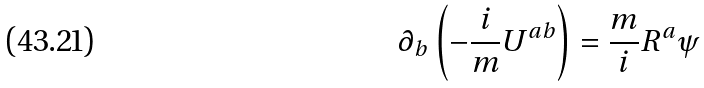<formula> <loc_0><loc_0><loc_500><loc_500>\partial _ { b } \left ( - \frac { i } { m } U ^ { a b } \right ) = \frac { m } { i } R ^ { a } \psi</formula> 